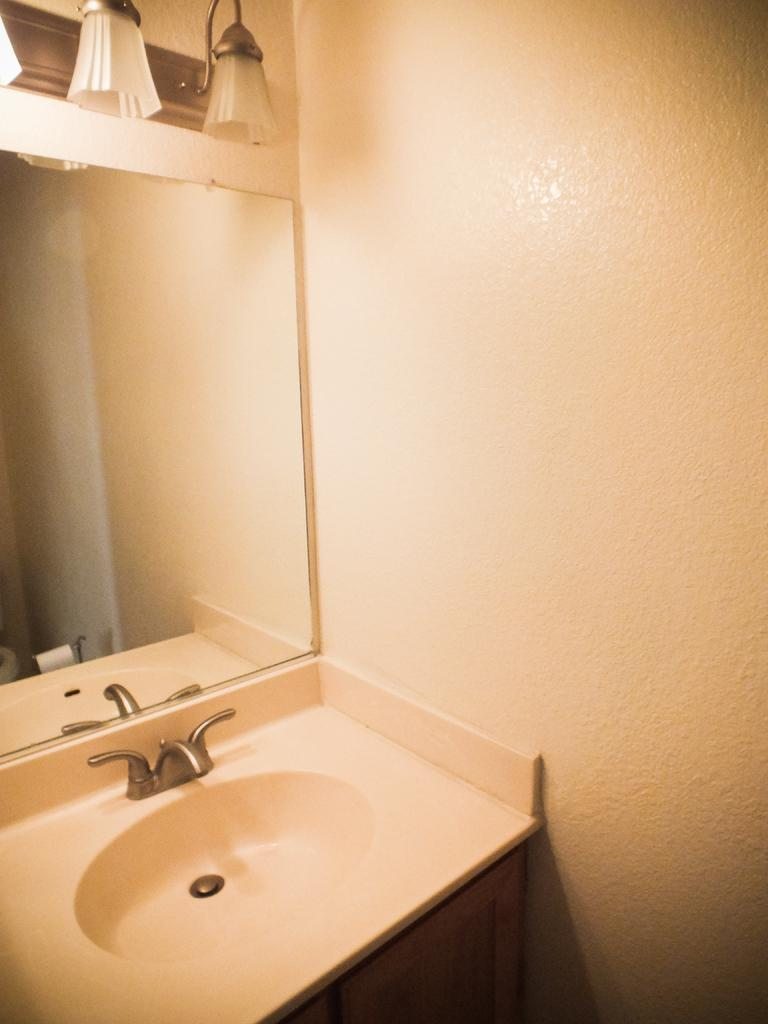What is one fixture that can be seen in the image? There is a sink in the image. What is another fixture that can be seen in the image? There is a mirror in the image. What type of lighting is present in the image? There are lights at the top of the image. What can be seen in the background of the image? There is a wall in the background of the image. What type of journey does the mirror take in the image? The mirror does not take a journey in the image; it is stationary on the wall. 